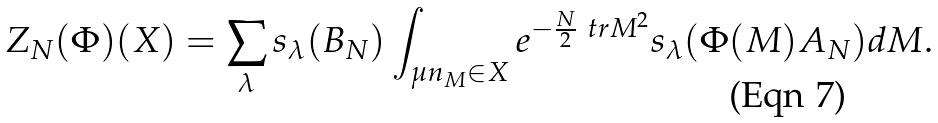Convert formula to latex. <formula><loc_0><loc_0><loc_500><loc_500>Z _ { N } ( \Phi ) ( X ) = \sum _ { \lambda } s _ { \lambda } ( B _ { N } ) \int _ { \mu n _ { M } \in X } e ^ { - \frac { N } { 2 } \ t r M ^ { 2 } } s _ { \lambda } ( \Phi ( M ) A _ { N } ) d M .</formula> 